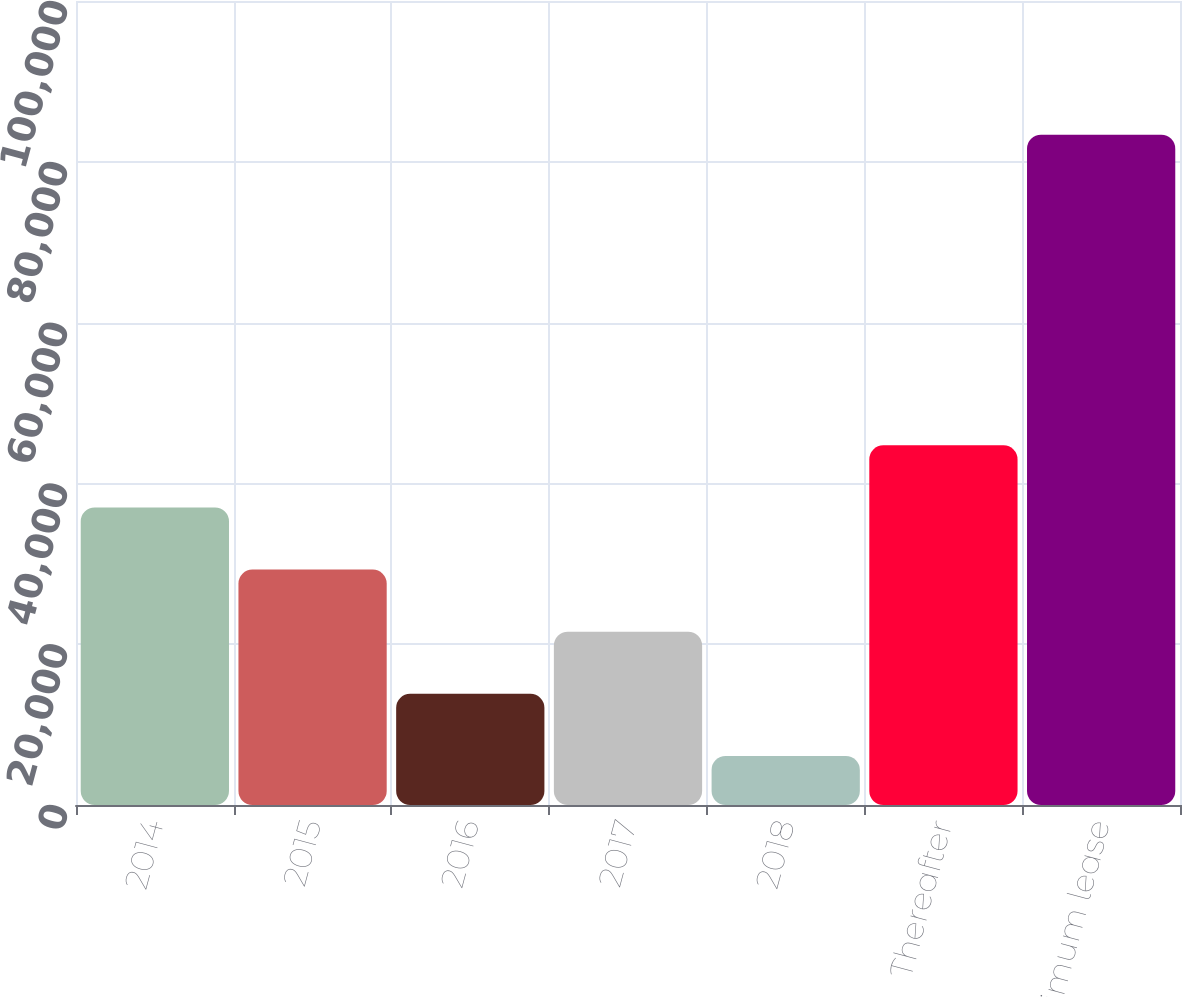Convert chart to OTSL. <chart><loc_0><loc_0><loc_500><loc_500><bar_chart><fcel>2014<fcel>2015<fcel>2016<fcel>2017<fcel>2018<fcel>Thereafter<fcel>Total minimum lease<nl><fcel>37013<fcel>29286<fcel>13832<fcel>21559<fcel>6105<fcel>44740<fcel>83375<nl></chart> 